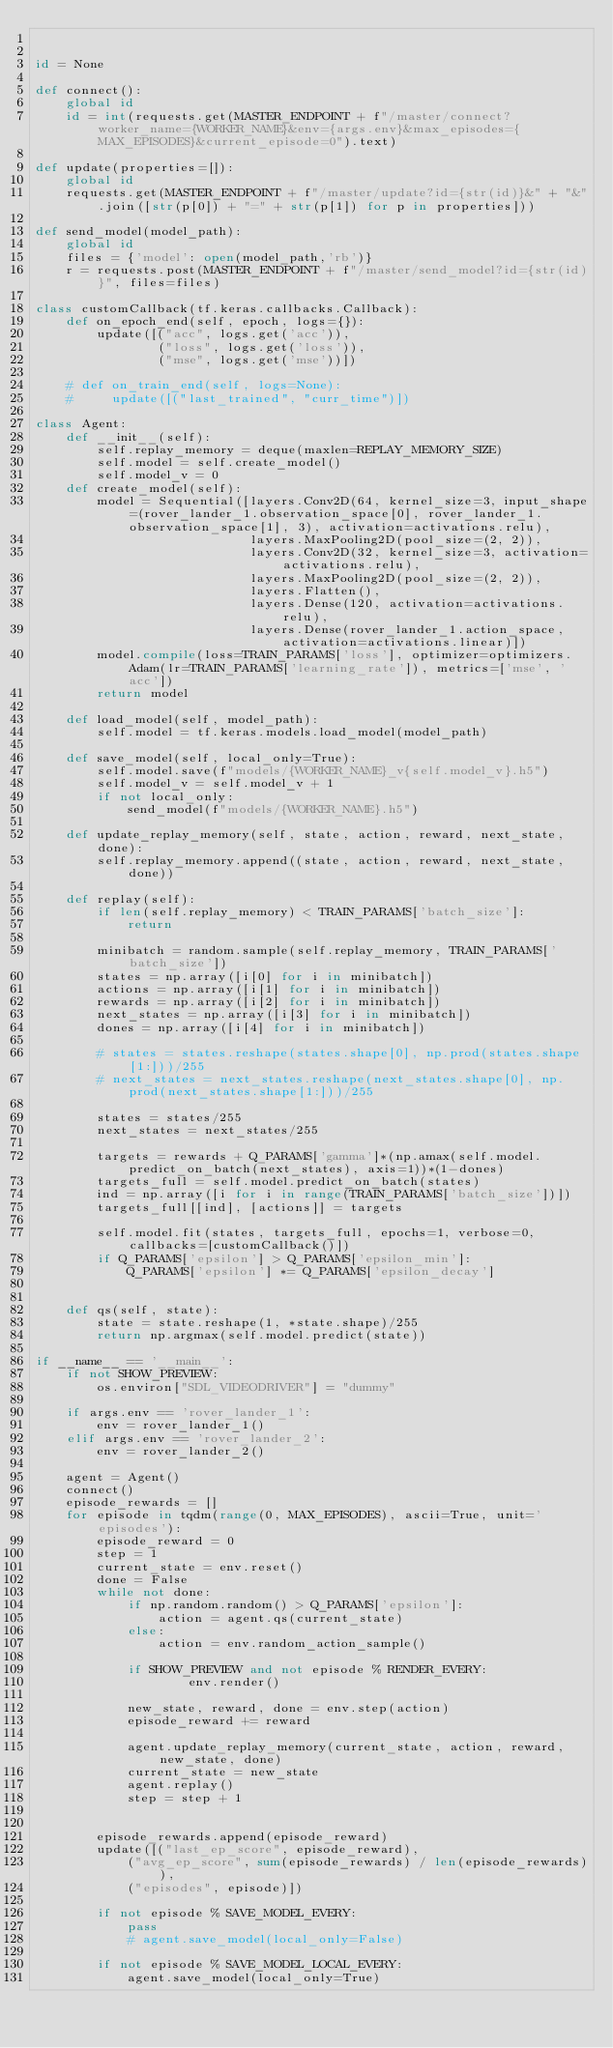<code> <loc_0><loc_0><loc_500><loc_500><_Python_>

id = None

def connect():
    global id
    id = int(requests.get(MASTER_ENDPOINT + f"/master/connect?worker_name={WORKER_NAME}&env={args.env}&max_episodes={MAX_EPISODES}&current_episode=0").text)
    
def update(properties=[]):
    global id
    requests.get(MASTER_ENDPOINT + f"/master/update?id={str(id)}&" + "&".join([str(p[0]) + "=" + str(p[1]) for p in properties]))
    
def send_model(model_path):
    global id
    files = {'model': open(model_path,'rb')}
    r = requests.post(MASTER_ENDPOINT + f"/master/send_model?id={str(id)}", files=files)
        
class customCallback(tf.keras.callbacks.Callback): 
    def on_epoch_end(self, epoch, logs={}): 
        update([("acc", logs.get('acc')),
                ("loss", logs.get('loss')),
                ("mse", logs.get('mse'))])
                
    # def on_train_end(self, logs=None):
    #     update([("last_trained", "curr_time")])
        
class Agent:
    def __init__(self):
        self.replay_memory = deque(maxlen=REPLAY_MEMORY_SIZE)
        self.model = self.create_model()
        self.model_v = 0
    def create_model(self):
        model = Sequential([layers.Conv2D(64, kernel_size=3, input_shape=(rover_lander_1.observation_space[0], rover_lander_1.observation_space[1], 3), activation=activations.relu),
                            layers.MaxPooling2D(pool_size=(2, 2)),
                            layers.Conv2D(32, kernel_size=3, activation=activations.relu),
                            layers.MaxPooling2D(pool_size=(2, 2)),
                            layers.Flatten(),
                            layers.Dense(120, activation=activations.relu),
                            layers.Dense(rover_lander_1.action_space, activation=activations.linear)])
        model.compile(loss=TRAIN_PARAMS['loss'], optimizer=optimizers.Adam(lr=TRAIN_PARAMS['learning_rate']), metrics=['mse', 'acc'])
        return model
    
    def load_model(self, model_path):
        self.model = tf.keras.models.load_model(model_path)
    
    def save_model(self, local_only=True):
        self.model.save(f"models/{WORKER_NAME}_v{self.model_v}.h5")
        self.model_v = self.model_v + 1
        if not local_only:
            send_model(f"models/{WORKER_NAME}.h5")
    
    def update_replay_memory(self, state, action, reward, next_state, done):
        self.replay_memory.append((state, action, reward, next_state, done))
    
    def replay(self):
        if len(self.replay_memory) < TRAIN_PARAMS['batch_size']:
            return
        
        minibatch = random.sample(self.replay_memory, TRAIN_PARAMS['batch_size'])
        states = np.array([i[0] for i in minibatch])
        actions = np.array([i[1] for i in minibatch])
        rewards = np.array([i[2] for i in minibatch])
        next_states = np.array([i[3] for i in minibatch])
        dones = np.array([i[4] for i in minibatch])

        # states = states.reshape(states.shape[0], np.prod(states.shape[1:]))/255
        # next_states = next_states.reshape(next_states.shape[0], np.prod(next_states.shape[1:]))/255
        
        states = states/255
        next_states = next_states/255
        
        targets = rewards + Q_PARAMS['gamma']*(np.amax(self.model.predict_on_batch(next_states), axis=1))*(1-dones)
        targets_full = self.model.predict_on_batch(states)
        ind = np.array([i for i in range(TRAIN_PARAMS['batch_size'])])
        targets_full[[ind], [actions]] = targets

        self.model.fit(states, targets_full, epochs=1, verbose=0, callbacks=[customCallback()])
        if Q_PARAMS['epsilon'] > Q_PARAMS['epsilon_min']:
            Q_PARAMS['epsilon'] *= Q_PARAMS['epsilon_decay']


    def qs(self, state):
        state = state.reshape(1, *state.shape)/255
        return np.argmax(self.model.predict(state))
        
if __name__ == '__main__':
    if not SHOW_PREVIEW:
        os.environ["SDL_VIDEODRIVER"] = "dummy"
        
    if args.env == 'rover_lander_1':
        env = rover_lander_1()
    elif args.env == 'rover_lander_2':
        env = rover_lander_2()
        
    agent = Agent()
    connect()
    episode_rewards = []
    for episode in tqdm(range(0, MAX_EPISODES), ascii=True, unit='episodes'):
        episode_reward = 0
        step = 1
        current_state = env.reset()
        done = False
        while not done:
            if np.random.random() > Q_PARAMS['epsilon']:
                action = agent.qs(current_state)
            else:
                action = env.random_action_sample()
                
            if SHOW_PREVIEW and not episode % RENDER_EVERY:
                    env.render()

            new_state, reward, done = env.step(action)
            episode_reward += reward
            
            agent.update_replay_memory(current_state, action, reward, new_state, done)
            current_state = new_state
            agent.replay()
            step = step + 1
            
                
        episode_rewards.append(episode_reward)
        update([("last_ep_score", episode_reward), 
            ("avg_ep_score", sum(episode_rewards) / len(episode_rewards)),
            ("episodes", episode)])
        
        if not episode % SAVE_MODEL_EVERY:
            pass
            # agent.save_model(local_only=False)
            
        if not episode % SAVE_MODEL_LOCAL_EVERY:
            agent.save_model(local_only=True)</code> 